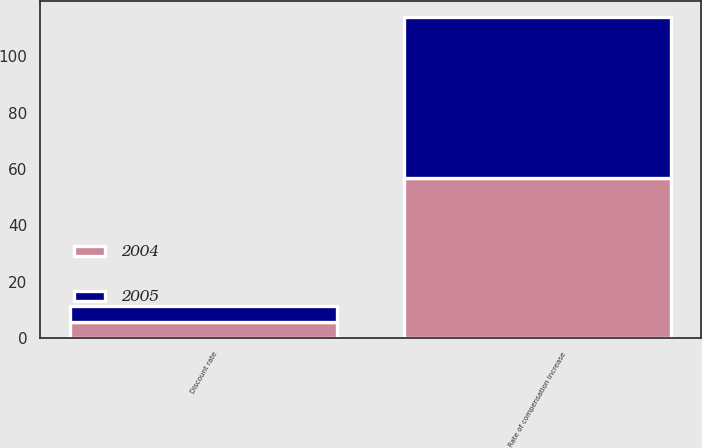Convert chart. <chart><loc_0><loc_0><loc_500><loc_500><stacked_bar_chart><ecel><fcel>Discount rate<fcel>Rate of compensation increase<nl><fcel>2004<fcel>5.5<fcel>57<nl><fcel>2005<fcel>5.75<fcel>57<nl></chart> 